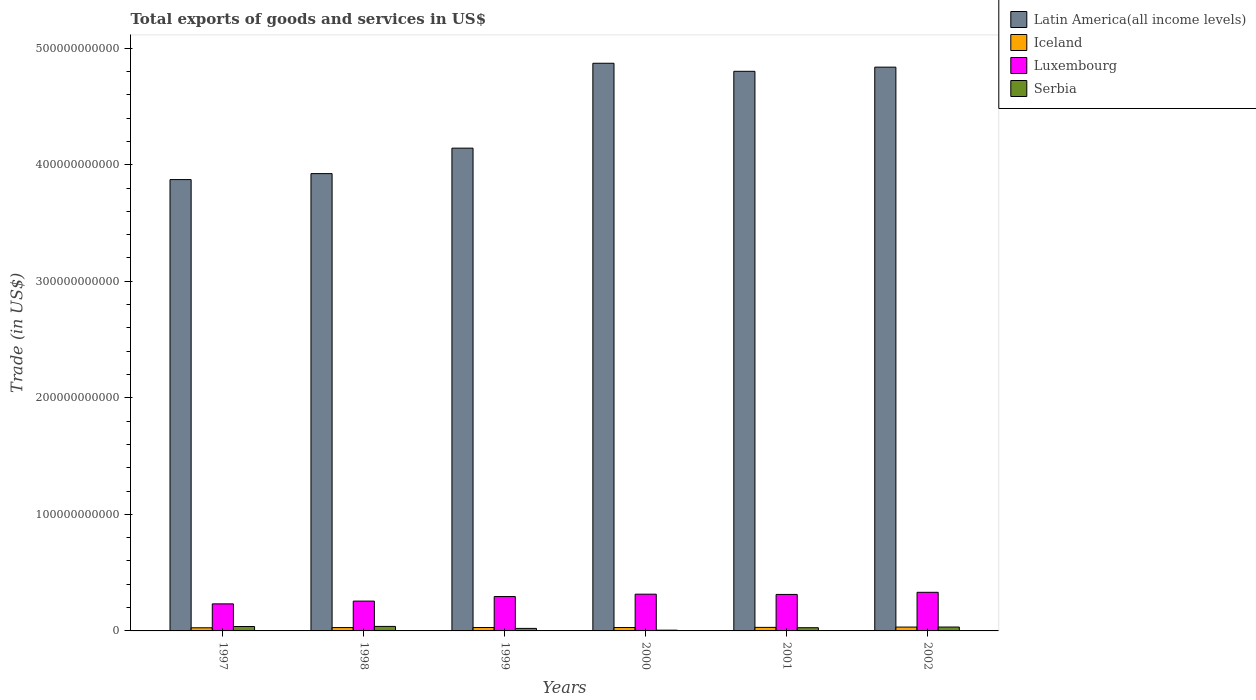How many different coloured bars are there?
Provide a short and direct response. 4. How many groups of bars are there?
Give a very brief answer. 6. How many bars are there on the 4th tick from the left?
Provide a succinct answer. 4. In how many cases, is the number of bars for a given year not equal to the number of legend labels?
Your answer should be very brief. 0. What is the total exports of goods and services in Iceland in 1998?
Provide a succinct answer. 2.87e+09. Across all years, what is the maximum total exports of goods and services in Latin America(all income levels)?
Make the answer very short. 4.87e+11. Across all years, what is the minimum total exports of goods and services in Latin America(all income levels)?
Make the answer very short. 3.87e+11. In which year was the total exports of goods and services in Iceland minimum?
Give a very brief answer. 1997. What is the total total exports of goods and services in Latin America(all income levels) in the graph?
Provide a succinct answer. 2.64e+12. What is the difference between the total exports of goods and services in Iceland in 1997 and that in 1998?
Give a very brief answer. -1.82e+08. What is the difference between the total exports of goods and services in Luxembourg in 2002 and the total exports of goods and services in Latin America(all income levels) in 1999?
Offer a terse response. -3.81e+11. What is the average total exports of goods and services in Iceland per year?
Offer a terse response. 2.95e+09. In the year 2001, what is the difference between the total exports of goods and services in Latin America(all income levels) and total exports of goods and services in Luxembourg?
Provide a succinct answer. 4.49e+11. In how many years, is the total exports of goods and services in Luxembourg greater than 40000000000 US$?
Your response must be concise. 0. What is the ratio of the total exports of goods and services in Latin America(all income levels) in 2000 to that in 2002?
Your answer should be very brief. 1.01. Is the total exports of goods and services in Serbia in 1997 less than that in 2001?
Your answer should be compact. No. Is the difference between the total exports of goods and services in Latin America(all income levels) in 1998 and 1999 greater than the difference between the total exports of goods and services in Luxembourg in 1998 and 1999?
Your answer should be very brief. No. What is the difference between the highest and the second highest total exports of goods and services in Serbia?
Provide a short and direct response. 8.64e+07. What is the difference between the highest and the lowest total exports of goods and services in Latin America(all income levels)?
Offer a very short reply. 9.98e+1. Is the sum of the total exports of goods and services in Serbia in 1999 and 2001 greater than the maximum total exports of goods and services in Latin America(all income levels) across all years?
Keep it short and to the point. No. What does the 2nd bar from the left in 1997 represents?
Your answer should be compact. Iceland. What does the 4th bar from the right in 2001 represents?
Provide a succinct answer. Latin America(all income levels). Is it the case that in every year, the sum of the total exports of goods and services in Iceland and total exports of goods and services in Luxembourg is greater than the total exports of goods and services in Latin America(all income levels)?
Your answer should be very brief. No. How many bars are there?
Offer a very short reply. 24. Are all the bars in the graph horizontal?
Ensure brevity in your answer.  No. What is the difference between two consecutive major ticks on the Y-axis?
Your response must be concise. 1.00e+11. Does the graph contain any zero values?
Your response must be concise. No. Does the graph contain grids?
Your response must be concise. No. Where does the legend appear in the graph?
Keep it short and to the point. Top right. What is the title of the graph?
Offer a terse response. Total exports of goods and services in US$. What is the label or title of the Y-axis?
Ensure brevity in your answer.  Trade (in US$). What is the Trade (in US$) of Latin America(all income levels) in 1997?
Your answer should be very brief. 3.87e+11. What is the Trade (in US$) of Iceland in 1997?
Your response must be concise. 2.69e+09. What is the Trade (in US$) of Luxembourg in 1997?
Offer a terse response. 2.32e+1. What is the Trade (in US$) in Serbia in 1997?
Give a very brief answer. 3.78e+09. What is the Trade (in US$) in Latin America(all income levels) in 1998?
Your answer should be compact. 3.92e+11. What is the Trade (in US$) in Iceland in 1998?
Keep it short and to the point. 2.87e+09. What is the Trade (in US$) in Luxembourg in 1998?
Ensure brevity in your answer.  2.56e+1. What is the Trade (in US$) of Serbia in 1998?
Make the answer very short. 3.87e+09. What is the Trade (in US$) of Latin America(all income levels) in 1999?
Keep it short and to the point. 4.14e+11. What is the Trade (in US$) of Iceland in 1999?
Provide a succinct answer. 2.92e+09. What is the Trade (in US$) in Luxembourg in 1999?
Give a very brief answer. 2.95e+1. What is the Trade (in US$) in Serbia in 1999?
Offer a very short reply. 2.16e+09. What is the Trade (in US$) of Latin America(all income levels) in 2000?
Keep it short and to the point. 4.87e+11. What is the Trade (in US$) in Iceland in 2000?
Your response must be concise. 2.90e+09. What is the Trade (in US$) in Luxembourg in 2000?
Keep it short and to the point. 3.15e+1. What is the Trade (in US$) of Serbia in 2000?
Give a very brief answer. 6.44e+08. What is the Trade (in US$) in Latin America(all income levels) in 2001?
Give a very brief answer. 4.80e+11. What is the Trade (in US$) of Iceland in 2001?
Provide a succinct answer. 3.04e+09. What is the Trade (in US$) in Luxembourg in 2001?
Provide a short and direct response. 3.13e+1. What is the Trade (in US$) in Serbia in 2001?
Provide a short and direct response. 2.75e+09. What is the Trade (in US$) of Latin America(all income levels) in 2002?
Ensure brevity in your answer.  4.84e+11. What is the Trade (in US$) of Iceland in 2002?
Your answer should be compact. 3.30e+09. What is the Trade (in US$) in Luxembourg in 2002?
Keep it short and to the point. 3.31e+1. What is the Trade (in US$) in Serbia in 2002?
Make the answer very short. 3.33e+09. Across all years, what is the maximum Trade (in US$) in Latin America(all income levels)?
Make the answer very short. 4.87e+11. Across all years, what is the maximum Trade (in US$) of Iceland?
Your answer should be compact. 3.30e+09. Across all years, what is the maximum Trade (in US$) of Luxembourg?
Make the answer very short. 3.31e+1. Across all years, what is the maximum Trade (in US$) in Serbia?
Make the answer very short. 3.87e+09. Across all years, what is the minimum Trade (in US$) in Latin America(all income levels)?
Provide a short and direct response. 3.87e+11. Across all years, what is the minimum Trade (in US$) in Iceland?
Provide a succinct answer. 2.69e+09. Across all years, what is the minimum Trade (in US$) of Luxembourg?
Your answer should be compact. 2.32e+1. Across all years, what is the minimum Trade (in US$) in Serbia?
Your answer should be compact. 6.44e+08. What is the total Trade (in US$) in Latin America(all income levels) in the graph?
Your answer should be compact. 2.64e+12. What is the total Trade (in US$) of Iceland in the graph?
Your answer should be compact. 1.77e+1. What is the total Trade (in US$) in Luxembourg in the graph?
Your response must be concise. 1.74e+11. What is the total Trade (in US$) in Serbia in the graph?
Your response must be concise. 1.65e+1. What is the difference between the Trade (in US$) of Latin America(all income levels) in 1997 and that in 1998?
Provide a short and direct response. -5.12e+09. What is the difference between the Trade (in US$) of Iceland in 1997 and that in 1998?
Keep it short and to the point. -1.82e+08. What is the difference between the Trade (in US$) in Luxembourg in 1997 and that in 1998?
Provide a succinct answer. -2.37e+09. What is the difference between the Trade (in US$) of Serbia in 1997 and that in 1998?
Provide a succinct answer. -8.64e+07. What is the difference between the Trade (in US$) of Latin America(all income levels) in 1997 and that in 1999?
Your answer should be compact. -2.70e+1. What is the difference between the Trade (in US$) of Iceland in 1997 and that in 1999?
Ensure brevity in your answer.  -2.25e+08. What is the difference between the Trade (in US$) in Luxembourg in 1997 and that in 1999?
Offer a terse response. -6.28e+09. What is the difference between the Trade (in US$) of Serbia in 1997 and that in 1999?
Your answer should be compact. 1.62e+09. What is the difference between the Trade (in US$) in Latin America(all income levels) in 1997 and that in 2000?
Give a very brief answer. -9.98e+1. What is the difference between the Trade (in US$) in Iceland in 1997 and that in 2000?
Provide a succinct answer. -2.10e+08. What is the difference between the Trade (in US$) in Luxembourg in 1997 and that in 2000?
Ensure brevity in your answer.  -8.31e+09. What is the difference between the Trade (in US$) in Serbia in 1997 and that in 2000?
Your answer should be compact. 3.14e+09. What is the difference between the Trade (in US$) of Latin America(all income levels) in 1997 and that in 2001?
Keep it short and to the point. -9.29e+1. What is the difference between the Trade (in US$) in Iceland in 1997 and that in 2001?
Provide a succinct answer. -3.51e+08. What is the difference between the Trade (in US$) of Luxembourg in 1997 and that in 2001?
Your response must be concise. -8.09e+09. What is the difference between the Trade (in US$) of Serbia in 1997 and that in 2001?
Offer a very short reply. 1.03e+09. What is the difference between the Trade (in US$) of Latin America(all income levels) in 1997 and that in 2002?
Provide a short and direct response. -9.65e+1. What is the difference between the Trade (in US$) of Iceland in 1997 and that in 2002?
Offer a very short reply. -6.13e+08. What is the difference between the Trade (in US$) of Luxembourg in 1997 and that in 2002?
Make the answer very short. -9.93e+09. What is the difference between the Trade (in US$) in Serbia in 1997 and that in 2002?
Provide a succinct answer. 4.55e+08. What is the difference between the Trade (in US$) in Latin America(all income levels) in 1998 and that in 1999?
Your answer should be very brief. -2.19e+1. What is the difference between the Trade (in US$) of Iceland in 1998 and that in 1999?
Your answer should be compact. -4.36e+07. What is the difference between the Trade (in US$) in Luxembourg in 1998 and that in 1999?
Make the answer very short. -3.91e+09. What is the difference between the Trade (in US$) in Serbia in 1998 and that in 1999?
Provide a succinct answer. 1.71e+09. What is the difference between the Trade (in US$) of Latin America(all income levels) in 1998 and that in 2000?
Provide a short and direct response. -9.47e+1. What is the difference between the Trade (in US$) in Iceland in 1998 and that in 2000?
Your response must be concise. -2.80e+07. What is the difference between the Trade (in US$) of Luxembourg in 1998 and that in 2000?
Keep it short and to the point. -5.94e+09. What is the difference between the Trade (in US$) of Serbia in 1998 and that in 2000?
Your answer should be very brief. 3.22e+09. What is the difference between the Trade (in US$) of Latin America(all income levels) in 1998 and that in 2001?
Ensure brevity in your answer.  -8.78e+1. What is the difference between the Trade (in US$) in Iceland in 1998 and that in 2001?
Give a very brief answer. -1.69e+08. What is the difference between the Trade (in US$) of Luxembourg in 1998 and that in 2001?
Make the answer very short. -5.72e+09. What is the difference between the Trade (in US$) in Serbia in 1998 and that in 2001?
Provide a succinct answer. 1.12e+09. What is the difference between the Trade (in US$) of Latin America(all income levels) in 1998 and that in 2002?
Your answer should be very brief. -9.14e+1. What is the difference between the Trade (in US$) in Iceland in 1998 and that in 2002?
Your response must be concise. -4.31e+08. What is the difference between the Trade (in US$) in Luxembourg in 1998 and that in 2002?
Your response must be concise. -7.55e+09. What is the difference between the Trade (in US$) of Serbia in 1998 and that in 2002?
Your answer should be very brief. 5.41e+08. What is the difference between the Trade (in US$) of Latin America(all income levels) in 1999 and that in 2000?
Offer a terse response. -7.28e+1. What is the difference between the Trade (in US$) of Iceland in 1999 and that in 2000?
Ensure brevity in your answer.  1.56e+07. What is the difference between the Trade (in US$) of Luxembourg in 1999 and that in 2000?
Offer a very short reply. -2.03e+09. What is the difference between the Trade (in US$) of Serbia in 1999 and that in 2000?
Keep it short and to the point. 1.52e+09. What is the difference between the Trade (in US$) of Latin America(all income levels) in 1999 and that in 2001?
Offer a very short reply. -6.59e+1. What is the difference between the Trade (in US$) in Iceland in 1999 and that in 2001?
Provide a short and direct response. -1.25e+08. What is the difference between the Trade (in US$) in Luxembourg in 1999 and that in 2001?
Make the answer very short. -1.81e+09. What is the difference between the Trade (in US$) in Serbia in 1999 and that in 2001?
Your answer should be very brief. -5.93e+08. What is the difference between the Trade (in US$) of Latin America(all income levels) in 1999 and that in 2002?
Offer a terse response. -6.95e+1. What is the difference between the Trade (in US$) of Iceland in 1999 and that in 2002?
Offer a very short reply. -3.87e+08. What is the difference between the Trade (in US$) of Luxembourg in 1999 and that in 2002?
Your answer should be compact. -3.64e+09. What is the difference between the Trade (in US$) of Serbia in 1999 and that in 2002?
Ensure brevity in your answer.  -1.17e+09. What is the difference between the Trade (in US$) in Latin America(all income levels) in 2000 and that in 2001?
Provide a short and direct response. 6.90e+09. What is the difference between the Trade (in US$) in Iceland in 2000 and that in 2001?
Make the answer very short. -1.41e+08. What is the difference between the Trade (in US$) of Luxembourg in 2000 and that in 2001?
Make the answer very short. 2.19e+08. What is the difference between the Trade (in US$) in Serbia in 2000 and that in 2001?
Keep it short and to the point. -2.11e+09. What is the difference between the Trade (in US$) in Latin America(all income levels) in 2000 and that in 2002?
Offer a terse response. 3.34e+09. What is the difference between the Trade (in US$) of Iceland in 2000 and that in 2002?
Offer a very short reply. -4.03e+08. What is the difference between the Trade (in US$) of Luxembourg in 2000 and that in 2002?
Your response must be concise. -1.62e+09. What is the difference between the Trade (in US$) in Serbia in 2000 and that in 2002?
Provide a short and direct response. -2.68e+09. What is the difference between the Trade (in US$) in Latin America(all income levels) in 2001 and that in 2002?
Offer a very short reply. -3.56e+09. What is the difference between the Trade (in US$) in Iceland in 2001 and that in 2002?
Offer a very short reply. -2.62e+08. What is the difference between the Trade (in US$) in Luxembourg in 2001 and that in 2002?
Keep it short and to the point. -1.84e+09. What is the difference between the Trade (in US$) in Serbia in 2001 and that in 2002?
Provide a short and direct response. -5.74e+08. What is the difference between the Trade (in US$) of Latin America(all income levels) in 1997 and the Trade (in US$) of Iceland in 1998?
Provide a succinct answer. 3.84e+11. What is the difference between the Trade (in US$) of Latin America(all income levels) in 1997 and the Trade (in US$) of Luxembourg in 1998?
Provide a succinct answer. 3.62e+11. What is the difference between the Trade (in US$) in Latin America(all income levels) in 1997 and the Trade (in US$) in Serbia in 1998?
Ensure brevity in your answer.  3.83e+11. What is the difference between the Trade (in US$) in Iceland in 1997 and the Trade (in US$) in Luxembourg in 1998?
Give a very brief answer. -2.29e+1. What is the difference between the Trade (in US$) of Iceland in 1997 and the Trade (in US$) of Serbia in 1998?
Keep it short and to the point. -1.18e+09. What is the difference between the Trade (in US$) of Luxembourg in 1997 and the Trade (in US$) of Serbia in 1998?
Ensure brevity in your answer.  1.93e+1. What is the difference between the Trade (in US$) of Latin America(all income levels) in 1997 and the Trade (in US$) of Iceland in 1999?
Offer a terse response. 3.84e+11. What is the difference between the Trade (in US$) in Latin America(all income levels) in 1997 and the Trade (in US$) in Luxembourg in 1999?
Offer a very short reply. 3.58e+11. What is the difference between the Trade (in US$) in Latin America(all income levels) in 1997 and the Trade (in US$) in Serbia in 1999?
Keep it short and to the point. 3.85e+11. What is the difference between the Trade (in US$) of Iceland in 1997 and the Trade (in US$) of Luxembourg in 1999?
Your answer should be very brief. -2.68e+1. What is the difference between the Trade (in US$) in Iceland in 1997 and the Trade (in US$) in Serbia in 1999?
Your answer should be very brief. 5.30e+08. What is the difference between the Trade (in US$) of Luxembourg in 1997 and the Trade (in US$) of Serbia in 1999?
Give a very brief answer. 2.11e+1. What is the difference between the Trade (in US$) of Latin America(all income levels) in 1997 and the Trade (in US$) of Iceland in 2000?
Give a very brief answer. 3.84e+11. What is the difference between the Trade (in US$) in Latin America(all income levels) in 1997 and the Trade (in US$) in Luxembourg in 2000?
Your answer should be very brief. 3.56e+11. What is the difference between the Trade (in US$) of Latin America(all income levels) in 1997 and the Trade (in US$) of Serbia in 2000?
Provide a succinct answer. 3.87e+11. What is the difference between the Trade (in US$) in Iceland in 1997 and the Trade (in US$) in Luxembourg in 2000?
Offer a very short reply. -2.88e+1. What is the difference between the Trade (in US$) in Iceland in 1997 and the Trade (in US$) in Serbia in 2000?
Keep it short and to the point. 2.05e+09. What is the difference between the Trade (in US$) of Luxembourg in 1997 and the Trade (in US$) of Serbia in 2000?
Your answer should be very brief. 2.26e+1. What is the difference between the Trade (in US$) in Latin America(all income levels) in 1997 and the Trade (in US$) in Iceland in 2001?
Your answer should be very brief. 3.84e+11. What is the difference between the Trade (in US$) of Latin America(all income levels) in 1997 and the Trade (in US$) of Luxembourg in 2001?
Keep it short and to the point. 3.56e+11. What is the difference between the Trade (in US$) of Latin America(all income levels) in 1997 and the Trade (in US$) of Serbia in 2001?
Your answer should be very brief. 3.84e+11. What is the difference between the Trade (in US$) in Iceland in 1997 and the Trade (in US$) in Luxembourg in 2001?
Your answer should be very brief. -2.86e+1. What is the difference between the Trade (in US$) in Iceland in 1997 and the Trade (in US$) in Serbia in 2001?
Make the answer very short. -6.34e+07. What is the difference between the Trade (in US$) in Luxembourg in 1997 and the Trade (in US$) in Serbia in 2001?
Give a very brief answer. 2.05e+1. What is the difference between the Trade (in US$) of Latin America(all income levels) in 1997 and the Trade (in US$) of Iceland in 2002?
Provide a succinct answer. 3.84e+11. What is the difference between the Trade (in US$) of Latin America(all income levels) in 1997 and the Trade (in US$) of Luxembourg in 2002?
Give a very brief answer. 3.54e+11. What is the difference between the Trade (in US$) in Latin America(all income levels) in 1997 and the Trade (in US$) in Serbia in 2002?
Offer a terse response. 3.84e+11. What is the difference between the Trade (in US$) of Iceland in 1997 and the Trade (in US$) of Luxembourg in 2002?
Your response must be concise. -3.04e+1. What is the difference between the Trade (in US$) of Iceland in 1997 and the Trade (in US$) of Serbia in 2002?
Offer a terse response. -6.38e+08. What is the difference between the Trade (in US$) of Luxembourg in 1997 and the Trade (in US$) of Serbia in 2002?
Offer a very short reply. 1.99e+1. What is the difference between the Trade (in US$) in Latin America(all income levels) in 1998 and the Trade (in US$) in Iceland in 1999?
Give a very brief answer. 3.89e+11. What is the difference between the Trade (in US$) in Latin America(all income levels) in 1998 and the Trade (in US$) in Luxembourg in 1999?
Offer a terse response. 3.63e+11. What is the difference between the Trade (in US$) of Latin America(all income levels) in 1998 and the Trade (in US$) of Serbia in 1999?
Offer a very short reply. 3.90e+11. What is the difference between the Trade (in US$) in Iceland in 1998 and the Trade (in US$) in Luxembourg in 1999?
Offer a very short reply. -2.66e+1. What is the difference between the Trade (in US$) of Iceland in 1998 and the Trade (in US$) of Serbia in 1999?
Keep it short and to the point. 7.12e+08. What is the difference between the Trade (in US$) in Luxembourg in 1998 and the Trade (in US$) in Serbia in 1999?
Give a very brief answer. 2.34e+1. What is the difference between the Trade (in US$) in Latin America(all income levels) in 1998 and the Trade (in US$) in Iceland in 2000?
Your answer should be compact. 3.89e+11. What is the difference between the Trade (in US$) in Latin America(all income levels) in 1998 and the Trade (in US$) in Luxembourg in 2000?
Keep it short and to the point. 3.61e+11. What is the difference between the Trade (in US$) of Latin America(all income levels) in 1998 and the Trade (in US$) of Serbia in 2000?
Offer a terse response. 3.92e+11. What is the difference between the Trade (in US$) in Iceland in 1998 and the Trade (in US$) in Luxembourg in 2000?
Offer a terse response. -2.87e+1. What is the difference between the Trade (in US$) of Iceland in 1998 and the Trade (in US$) of Serbia in 2000?
Offer a very short reply. 2.23e+09. What is the difference between the Trade (in US$) of Luxembourg in 1998 and the Trade (in US$) of Serbia in 2000?
Make the answer very short. 2.49e+1. What is the difference between the Trade (in US$) of Latin America(all income levels) in 1998 and the Trade (in US$) of Iceland in 2001?
Provide a succinct answer. 3.89e+11. What is the difference between the Trade (in US$) of Latin America(all income levels) in 1998 and the Trade (in US$) of Luxembourg in 2001?
Provide a succinct answer. 3.61e+11. What is the difference between the Trade (in US$) in Latin America(all income levels) in 1998 and the Trade (in US$) in Serbia in 2001?
Give a very brief answer. 3.90e+11. What is the difference between the Trade (in US$) of Iceland in 1998 and the Trade (in US$) of Luxembourg in 2001?
Provide a succinct answer. -2.84e+1. What is the difference between the Trade (in US$) in Iceland in 1998 and the Trade (in US$) in Serbia in 2001?
Your response must be concise. 1.18e+08. What is the difference between the Trade (in US$) in Luxembourg in 1998 and the Trade (in US$) in Serbia in 2001?
Provide a succinct answer. 2.28e+1. What is the difference between the Trade (in US$) in Latin America(all income levels) in 1998 and the Trade (in US$) in Iceland in 2002?
Offer a terse response. 3.89e+11. What is the difference between the Trade (in US$) of Latin America(all income levels) in 1998 and the Trade (in US$) of Luxembourg in 2002?
Offer a very short reply. 3.59e+11. What is the difference between the Trade (in US$) in Latin America(all income levels) in 1998 and the Trade (in US$) in Serbia in 2002?
Your answer should be compact. 3.89e+11. What is the difference between the Trade (in US$) in Iceland in 1998 and the Trade (in US$) in Luxembourg in 2002?
Give a very brief answer. -3.03e+1. What is the difference between the Trade (in US$) of Iceland in 1998 and the Trade (in US$) of Serbia in 2002?
Your response must be concise. -4.56e+08. What is the difference between the Trade (in US$) in Luxembourg in 1998 and the Trade (in US$) in Serbia in 2002?
Provide a short and direct response. 2.23e+1. What is the difference between the Trade (in US$) in Latin America(all income levels) in 1999 and the Trade (in US$) in Iceland in 2000?
Give a very brief answer. 4.11e+11. What is the difference between the Trade (in US$) in Latin America(all income levels) in 1999 and the Trade (in US$) in Luxembourg in 2000?
Give a very brief answer. 3.83e+11. What is the difference between the Trade (in US$) of Latin America(all income levels) in 1999 and the Trade (in US$) of Serbia in 2000?
Give a very brief answer. 4.14e+11. What is the difference between the Trade (in US$) of Iceland in 1999 and the Trade (in US$) of Luxembourg in 2000?
Your response must be concise. -2.86e+1. What is the difference between the Trade (in US$) of Iceland in 1999 and the Trade (in US$) of Serbia in 2000?
Keep it short and to the point. 2.27e+09. What is the difference between the Trade (in US$) of Luxembourg in 1999 and the Trade (in US$) of Serbia in 2000?
Provide a short and direct response. 2.88e+1. What is the difference between the Trade (in US$) of Latin America(all income levels) in 1999 and the Trade (in US$) of Iceland in 2001?
Keep it short and to the point. 4.11e+11. What is the difference between the Trade (in US$) of Latin America(all income levels) in 1999 and the Trade (in US$) of Luxembourg in 2001?
Offer a terse response. 3.83e+11. What is the difference between the Trade (in US$) of Latin America(all income levels) in 1999 and the Trade (in US$) of Serbia in 2001?
Keep it short and to the point. 4.11e+11. What is the difference between the Trade (in US$) in Iceland in 1999 and the Trade (in US$) in Luxembourg in 2001?
Your answer should be compact. -2.84e+1. What is the difference between the Trade (in US$) of Iceland in 1999 and the Trade (in US$) of Serbia in 2001?
Make the answer very short. 1.62e+08. What is the difference between the Trade (in US$) in Luxembourg in 1999 and the Trade (in US$) in Serbia in 2001?
Give a very brief answer. 2.67e+1. What is the difference between the Trade (in US$) of Latin America(all income levels) in 1999 and the Trade (in US$) of Iceland in 2002?
Your answer should be very brief. 4.11e+11. What is the difference between the Trade (in US$) of Latin America(all income levels) in 1999 and the Trade (in US$) of Luxembourg in 2002?
Give a very brief answer. 3.81e+11. What is the difference between the Trade (in US$) in Latin America(all income levels) in 1999 and the Trade (in US$) in Serbia in 2002?
Give a very brief answer. 4.11e+11. What is the difference between the Trade (in US$) in Iceland in 1999 and the Trade (in US$) in Luxembourg in 2002?
Your answer should be very brief. -3.02e+1. What is the difference between the Trade (in US$) in Iceland in 1999 and the Trade (in US$) in Serbia in 2002?
Give a very brief answer. -4.12e+08. What is the difference between the Trade (in US$) of Luxembourg in 1999 and the Trade (in US$) of Serbia in 2002?
Provide a succinct answer. 2.62e+1. What is the difference between the Trade (in US$) in Latin America(all income levels) in 2000 and the Trade (in US$) in Iceland in 2001?
Keep it short and to the point. 4.84e+11. What is the difference between the Trade (in US$) in Latin America(all income levels) in 2000 and the Trade (in US$) in Luxembourg in 2001?
Provide a succinct answer. 4.56e+11. What is the difference between the Trade (in US$) of Latin America(all income levels) in 2000 and the Trade (in US$) of Serbia in 2001?
Provide a succinct answer. 4.84e+11. What is the difference between the Trade (in US$) in Iceland in 2000 and the Trade (in US$) in Luxembourg in 2001?
Your answer should be very brief. -2.84e+1. What is the difference between the Trade (in US$) of Iceland in 2000 and the Trade (in US$) of Serbia in 2001?
Your answer should be very brief. 1.46e+08. What is the difference between the Trade (in US$) of Luxembourg in 2000 and the Trade (in US$) of Serbia in 2001?
Offer a terse response. 2.88e+1. What is the difference between the Trade (in US$) of Latin America(all income levels) in 2000 and the Trade (in US$) of Iceland in 2002?
Keep it short and to the point. 4.84e+11. What is the difference between the Trade (in US$) in Latin America(all income levels) in 2000 and the Trade (in US$) in Luxembourg in 2002?
Keep it short and to the point. 4.54e+11. What is the difference between the Trade (in US$) of Latin America(all income levels) in 2000 and the Trade (in US$) of Serbia in 2002?
Ensure brevity in your answer.  4.84e+11. What is the difference between the Trade (in US$) of Iceland in 2000 and the Trade (in US$) of Luxembourg in 2002?
Your answer should be compact. -3.02e+1. What is the difference between the Trade (in US$) of Iceland in 2000 and the Trade (in US$) of Serbia in 2002?
Offer a very short reply. -4.28e+08. What is the difference between the Trade (in US$) of Luxembourg in 2000 and the Trade (in US$) of Serbia in 2002?
Provide a succinct answer. 2.82e+1. What is the difference between the Trade (in US$) in Latin America(all income levels) in 2001 and the Trade (in US$) in Iceland in 2002?
Make the answer very short. 4.77e+11. What is the difference between the Trade (in US$) in Latin America(all income levels) in 2001 and the Trade (in US$) in Luxembourg in 2002?
Provide a succinct answer. 4.47e+11. What is the difference between the Trade (in US$) in Latin America(all income levels) in 2001 and the Trade (in US$) in Serbia in 2002?
Give a very brief answer. 4.77e+11. What is the difference between the Trade (in US$) in Iceland in 2001 and the Trade (in US$) in Luxembourg in 2002?
Your response must be concise. -3.01e+1. What is the difference between the Trade (in US$) in Iceland in 2001 and the Trade (in US$) in Serbia in 2002?
Ensure brevity in your answer.  -2.87e+08. What is the difference between the Trade (in US$) of Luxembourg in 2001 and the Trade (in US$) of Serbia in 2002?
Keep it short and to the point. 2.80e+1. What is the average Trade (in US$) in Latin America(all income levels) per year?
Offer a very short reply. 4.41e+11. What is the average Trade (in US$) of Iceland per year?
Ensure brevity in your answer.  2.95e+09. What is the average Trade (in US$) of Luxembourg per year?
Your response must be concise. 2.90e+1. What is the average Trade (in US$) in Serbia per year?
Make the answer very short. 2.76e+09. In the year 1997, what is the difference between the Trade (in US$) in Latin America(all income levels) and Trade (in US$) in Iceland?
Provide a short and direct response. 3.85e+11. In the year 1997, what is the difference between the Trade (in US$) in Latin America(all income levels) and Trade (in US$) in Luxembourg?
Your response must be concise. 3.64e+11. In the year 1997, what is the difference between the Trade (in US$) in Latin America(all income levels) and Trade (in US$) in Serbia?
Offer a terse response. 3.83e+11. In the year 1997, what is the difference between the Trade (in US$) in Iceland and Trade (in US$) in Luxembourg?
Keep it short and to the point. -2.05e+1. In the year 1997, what is the difference between the Trade (in US$) of Iceland and Trade (in US$) of Serbia?
Your response must be concise. -1.09e+09. In the year 1997, what is the difference between the Trade (in US$) in Luxembourg and Trade (in US$) in Serbia?
Offer a terse response. 1.94e+1. In the year 1998, what is the difference between the Trade (in US$) in Latin America(all income levels) and Trade (in US$) in Iceland?
Keep it short and to the point. 3.89e+11. In the year 1998, what is the difference between the Trade (in US$) of Latin America(all income levels) and Trade (in US$) of Luxembourg?
Your answer should be very brief. 3.67e+11. In the year 1998, what is the difference between the Trade (in US$) of Latin America(all income levels) and Trade (in US$) of Serbia?
Your answer should be compact. 3.88e+11. In the year 1998, what is the difference between the Trade (in US$) of Iceland and Trade (in US$) of Luxembourg?
Keep it short and to the point. -2.27e+1. In the year 1998, what is the difference between the Trade (in US$) of Iceland and Trade (in US$) of Serbia?
Your response must be concise. -9.97e+08. In the year 1998, what is the difference between the Trade (in US$) in Luxembourg and Trade (in US$) in Serbia?
Make the answer very short. 2.17e+1. In the year 1999, what is the difference between the Trade (in US$) in Latin America(all income levels) and Trade (in US$) in Iceland?
Offer a very short reply. 4.11e+11. In the year 1999, what is the difference between the Trade (in US$) in Latin America(all income levels) and Trade (in US$) in Luxembourg?
Provide a short and direct response. 3.85e+11. In the year 1999, what is the difference between the Trade (in US$) of Latin America(all income levels) and Trade (in US$) of Serbia?
Provide a short and direct response. 4.12e+11. In the year 1999, what is the difference between the Trade (in US$) in Iceland and Trade (in US$) in Luxembourg?
Provide a short and direct response. -2.66e+1. In the year 1999, what is the difference between the Trade (in US$) in Iceland and Trade (in US$) in Serbia?
Provide a short and direct response. 7.55e+08. In the year 1999, what is the difference between the Trade (in US$) in Luxembourg and Trade (in US$) in Serbia?
Make the answer very short. 2.73e+1. In the year 2000, what is the difference between the Trade (in US$) of Latin America(all income levels) and Trade (in US$) of Iceland?
Provide a short and direct response. 4.84e+11. In the year 2000, what is the difference between the Trade (in US$) in Latin America(all income levels) and Trade (in US$) in Luxembourg?
Ensure brevity in your answer.  4.56e+11. In the year 2000, what is the difference between the Trade (in US$) of Latin America(all income levels) and Trade (in US$) of Serbia?
Provide a succinct answer. 4.86e+11. In the year 2000, what is the difference between the Trade (in US$) of Iceland and Trade (in US$) of Luxembourg?
Your answer should be compact. -2.86e+1. In the year 2000, what is the difference between the Trade (in US$) of Iceland and Trade (in US$) of Serbia?
Provide a short and direct response. 2.26e+09. In the year 2000, what is the difference between the Trade (in US$) of Luxembourg and Trade (in US$) of Serbia?
Give a very brief answer. 3.09e+1. In the year 2001, what is the difference between the Trade (in US$) in Latin America(all income levels) and Trade (in US$) in Iceland?
Give a very brief answer. 4.77e+11. In the year 2001, what is the difference between the Trade (in US$) of Latin America(all income levels) and Trade (in US$) of Luxembourg?
Ensure brevity in your answer.  4.49e+11. In the year 2001, what is the difference between the Trade (in US$) of Latin America(all income levels) and Trade (in US$) of Serbia?
Make the answer very short. 4.77e+11. In the year 2001, what is the difference between the Trade (in US$) of Iceland and Trade (in US$) of Luxembourg?
Make the answer very short. -2.83e+1. In the year 2001, what is the difference between the Trade (in US$) in Iceland and Trade (in US$) in Serbia?
Give a very brief answer. 2.87e+08. In the year 2001, what is the difference between the Trade (in US$) in Luxembourg and Trade (in US$) in Serbia?
Provide a succinct answer. 2.86e+1. In the year 2002, what is the difference between the Trade (in US$) of Latin America(all income levels) and Trade (in US$) of Iceland?
Give a very brief answer. 4.80e+11. In the year 2002, what is the difference between the Trade (in US$) of Latin America(all income levels) and Trade (in US$) of Luxembourg?
Offer a terse response. 4.51e+11. In the year 2002, what is the difference between the Trade (in US$) of Latin America(all income levels) and Trade (in US$) of Serbia?
Keep it short and to the point. 4.80e+11. In the year 2002, what is the difference between the Trade (in US$) of Iceland and Trade (in US$) of Luxembourg?
Provide a short and direct response. -2.98e+1. In the year 2002, what is the difference between the Trade (in US$) in Iceland and Trade (in US$) in Serbia?
Offer a very short reply. -2.48e+07. In the year 2002, what is the difference between the Trade (in US$) of Luxembourg and Trade (in US$) of Serbia?
Provide a succinct answer. 2.98e+1. What is the ratio of the Trade (in US$) in Latin America(all income levels) in 1997 to that in 1998?
Provide a succinct answer. 0.99. What is the ratio of the Trade (in US$) of Iceland in 1997 to that in 1998?
Provide a short and direct response. 0.94. What is the ratio of the Trade (in US$) in Luxembourg in 1997 to that in 1998?
Provide a short and direct response. 0.91. What is the ratio of the Trade (in US$) in Serbia in 1997 to that in 1998?
Your answer should be compact. 0.98. What is the ratio of the Trade (in US$) of Latin America(all income levels) in 1997 to that in 1999?
Provide a short and direct response. 0.93. What is the ratio of the Trade (in US$) in Iceland in 1997 to that in 1999?
Offer a very short reply. 0.92. What is the ratio of the Trade (in US$) of Luxembourg in 1997 to that in 1999?
Offer a terse response. 0.79. What is the ratio of the Trade (in US$) of Serbia in 1997 to that in 1999?
Offer a very short reply. 1.75. What is the ratio of the Trade (in US$) of Latin America(all income levels) in 1997 to that in 2000?
Offer a terse response. 0.8. What is the ratio of the Trade (in US$) in Iceland in 1997 to that in 2000?
Your answer should be very brief. 0.93. What is the ratio of the Trade (in US$) of Luxembourg in 1997 to that in 2000?
Offer a very short reply. 0.74. What is the ratio of the Trade (in US$) of Serbia in 1997 to that in 2000?
Make the answer very short. 5.87. What is the ratio of the Trade (in US$) in Latin America(all income levels) in 1997 to that in 2001?
Make the answer very short. 0.81. What is the ratio of the Trade (in US$) of Iceland in 1997 to that in 2001?
Give a very brief answer. 0.88. What is the ratio of the Trade (in US$) of Luxembourg in 1997 to that in 2001?
Your response must be concise. 0.74. What is the ratio of the Trade (in US$) of Serbia in 1997 to that in 2001?
Provide a short and direct response. 1.37. What is the ratio of the Trade (in US$) of Latin America(all income levels) in 1997 to that in 2002?
Make the answer very short. 0.8. What is the ratio of the Trade (in US$) in Iceland in 1997 to that in 2002?
Make the answer very short. 0.81. What is the ratio of the Trade (in US$) in Luxembourg in 1997 to that in 2002?
Your response must be concise. 0.7. What is the ratio of the Trade (in US$) in Serbia in 1997 to that in 2002?
Your answer should be very brief. 1.14. What is the ratio of the Trade (in US$) in Latin America(all income levels) in 1998 to that in 1999?
Give a very brief answer. 0.95. What is the ratio of the Trade (in US$) in Iceland in 1998 to that in 1999?
Ensure brevity in your answer.  0.98. What is the ratio of the Trade (in US$) in Luxembourg in 1998 to that in 1999?
Your answer should be very brief. 0.87. What is the ratio of the Trade (in US$) in Serbia in 1998 to that in 1999?
Keep it short and to the point. 1.79. What is the ratio of the Trade (in US$) of Latin America(all income levels) in 1998 to that in 2000?
Offer a very short reply. 0.81. What is the ratio of the Trade (in US$) in Iceland in 1998 to that in 2000?
Your answer should be compact. 0.99. What is the ratio of the Trade (in US$) in Luxembourg in 1998 to that in 2000?
Provide a succinct answer. 0.81. What is the ratio of the Trade (in US$) in Serbia in 1998 to that in 2000?
Make the answer very short. 6. What is the ratio of the Trade (in US$) of Latin America(all income levels) in 1998 to that in 2001?
Ensure brevity in your answer.  0.82. What is the ratio of the Trade (in US$) in Iceland in 1998 to that in 2001?
Keep it short and to the point. 0.94. What is the ratio of the Trade (in US$) of Luxembourg in 1998 to that in 2001?
Keep it short and to the point. 0.82. What is the ratio of the Trade (in US$) of Serbia in 1998 to that in 2001?
Your response must be concise. 1.41. What is the ratio of the Trade (in US$) of Latin America(all income levels) in 1998 to that in 2002?
Offer a very short reply. 0.81. What is the ratio of the Trade (in US$) in Iceland in 1998 to that in 2002?
Offer a terse response. 0.87. What is the ratio of the Trade (in US$) in Luxembourg in 1998 to that in 2002?
Provide a succinct answer. 0.77. What is the ratio of the Trade (in US$) of Serbia in 1998 to that in 2002?
Offer a very short reply. 1.16. What is the ratio of the Trade (in US$) of Latin America(all income levels) in 1999 to that in 2000?
Offer a terse response. 0.85. What is the ratio of the Trade (in US$) of Iceland in 1999 to that in 2000?
Keep it short and to the point. 1.01. What is the ratio of the Trade (in US$) of Luxembourg in 1999 to that in 2000?
Offer a terse response. 0.94. What is the ratio of the Trade (in US$) of Serbia in 1999 to that in 2000?
Offer a very short reply. 3.35. What is the ratio of the Trade (in US$) of Latin America(all income levels) in 1999 to that in 2001?
Keep it short and to the point. 0.86. What is the ratio of the Trade (in US$) of Iceland in 1999 to that in 2001?
Offer a very short reply. 0.96. What is the ratio of the Trade (in US$) of Luxembourg in 1999 to that in 2001?
Your response must be concise. 0.94. What is the ratio of the Trade (in US$) of Serbia in 1999 to that in 2001?
Provide a succinct answer. 0.78. What is the ratio of the Trade (in US$) in Latin America(all income levels) in 1999 to that in 2002?
Your answer should be compact. 0.86. What is the ratio of the Trade (in US$) of Iceland in 1999 to that in 2002?
Make the answer very short. 0.88. What is the ratio of the Trade (in US$) in Luxembourg in 1999 to that in 2002?
Ensure brevity in your answer.  0.89. What is the ratio of the Trade (in US$) of Serbia in 1999 to that in 2002?
Keep it short and to the point. 0.65. What is the ratio of the Trade (in US$) in Latin America(all income levels) in 2000 to that in 2001?
Your answer should be very brief. 1.01. What is the ratio of the Trade (in US$) in Iceland in 2000 to that in 2001?
Provide a short and direct response. 0.95. What is the ratio of the Trade (in US$) of Luxembourg in 2000 to that in 2001?
Ensure brevity in your answer.  1.01. What is the ratio of the Trade (in US$) in Serbia in 2000 to that in 2001?
Ensure brevity in your answer.  0.23. What is the ratio of the Trade (in US$) in Latin America(all income levels) in 2000 to that in 2002?
Give a very brief answer. 1.01. What is the ratio of the Trade (in US$) of Iceland in 2000 to that in 2002?
Provide a short and direct response. 0.88. What is the ratio of the Trade (in US$) of Luxembourg in 2000 to that in 2002?
Provide a succinct answer. 0.95. What is the ratio of the Trade (in US$) in Serbia in 2000 to that in 2002?
Ensure brevity in your answer.  0.19. What is the ratio of the Trade (in US$) in Latin America(all income levels) in 2001 to that in 2002?
Make the answer very short. 0.99. What is the ratio of the Trade (in US$) in Iceland in 2001 to that in 2002?
Your answer should be compact. 0.92. What is the ratio of the Trade (in US$) of Luxembourg in 2001 to that in 2002?
Make the answer very short. 0.94. What is the ratio of the Trade (in US$) in Serbia in 2001 to that in 2002?
Ensure brevity in your answer.  0.83. What is the difference between the highest and the second highest Trade (in US$) in Latin America(all income levels)?
Give a very brief answer. 3.34e+09. What is the difference between the highest and the second highest Trade (in US$) in Iceland?
Your response must be concise. 2.62e+08. What is the difference between the highest and the second highest Trade (in US$) of Luxembourg?
Give a very brief answer. 1.62e+09. What is the difference between the highest and the second highest Trade (in US$) in Serbia?
Ensure brevity in your answer.  8.64e+07. What is the difference between the highest and the lowest Trade (in US$) in Latin America(all income levels)?
Offer a terse response. 9.98e+1. What is the difference between the highest and the lowest Trade (in US$) in Iceland?
Keep it short and to the point. 6.13e+08. What is the difference between the highest and the lowest Trade (in US$) in Luxembourg?
Provide a short and direct response. 9.93e+09. What is the difference between the highest and the lowest Trade (in US$) of Serbia?
Provide a short and direct response. 3.22e+09. 